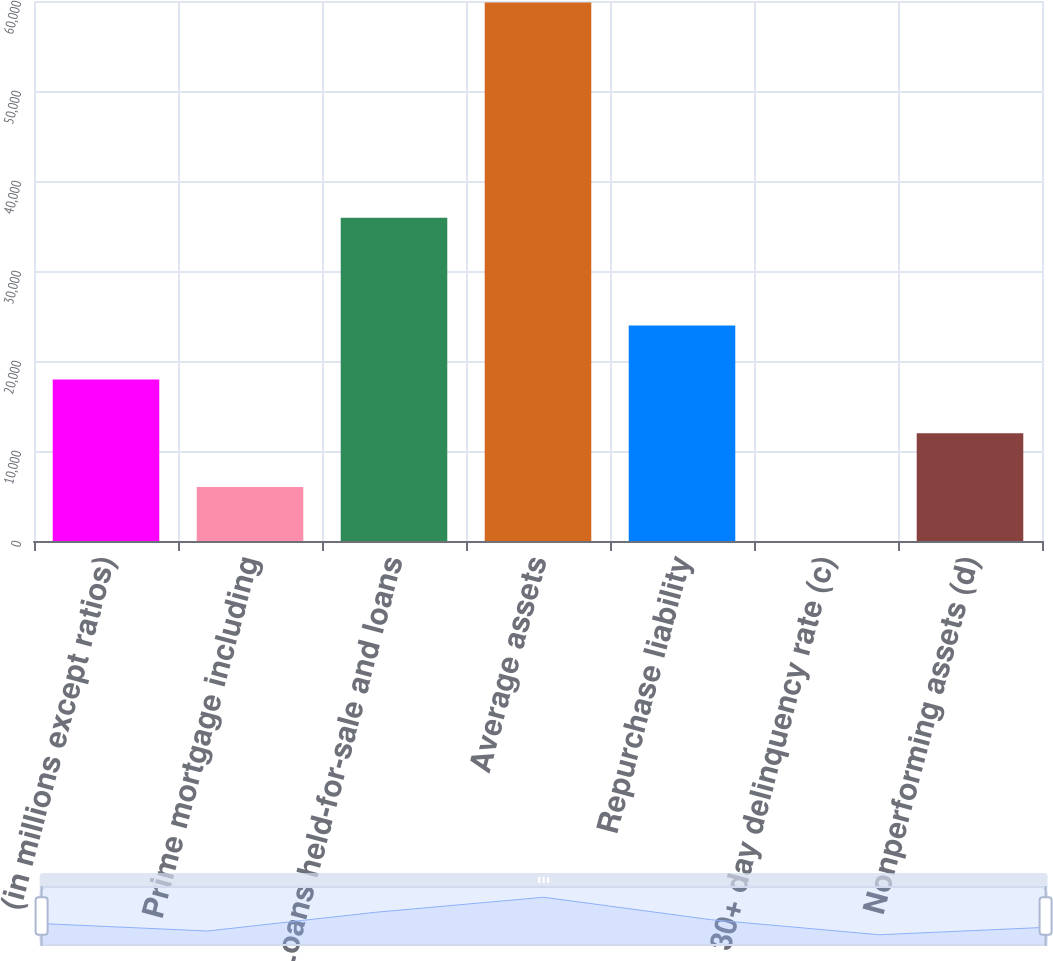Convert chart to OTSL. <chart><loc_0><loc_0><loc_500><loc_500><bar_chart><fcel>(in millions except ratios)<fcel>Prime mortgage including<fcel>Loans held-for-sale and loans<fcel>Average assets<fcel>Repurchase liability<fcel>30+ day delinquency rate (c)<fcel>Nonperforming assets (d)<nl><fcel>17953.2<fcel>5986.45<fcel>35903.4<fcel>59837<fcel>23936.7<fcel>3.05<fcel>11969.9<nl></chart> 